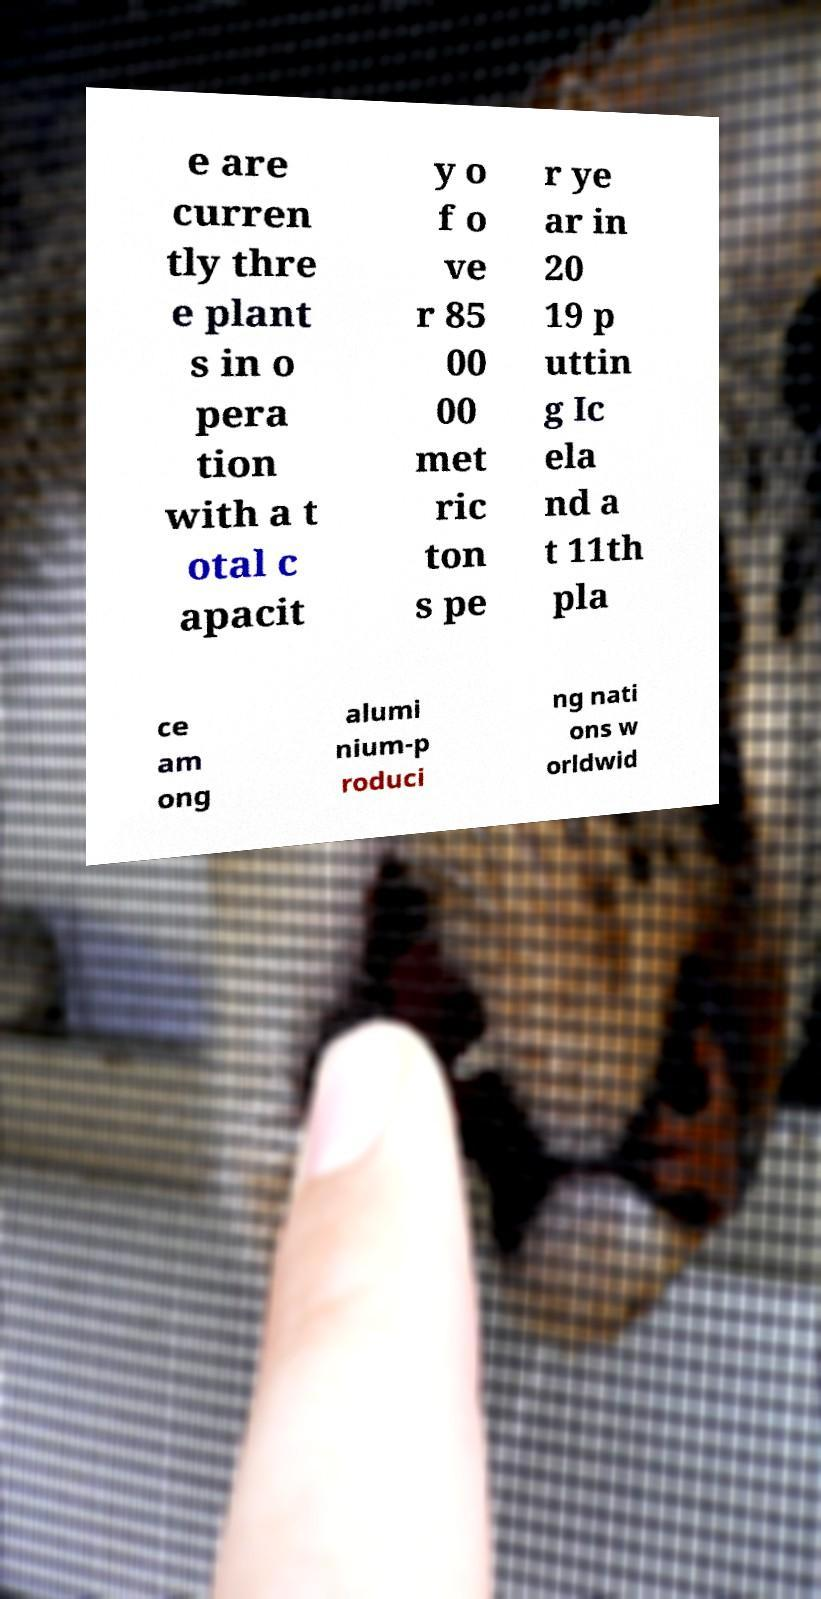Could you extract and type out the text from this image? e are curren tly thre e plant s in o pera tion with a t otal c apacit y o f o ve r 85 00 00 met ric ton s pe r ye ar in 20 19 p uttin g Ic ela nd a t 11th pla ce am ong alumi nium-p roduci ng nati ons w orldwid 